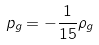Convert formula to latex. <formula><loc_0><loc_0><loc_500><loc_500>p _ { g } = - \frac { 1 } { 1 5 } \rho _ { g }</formula> 